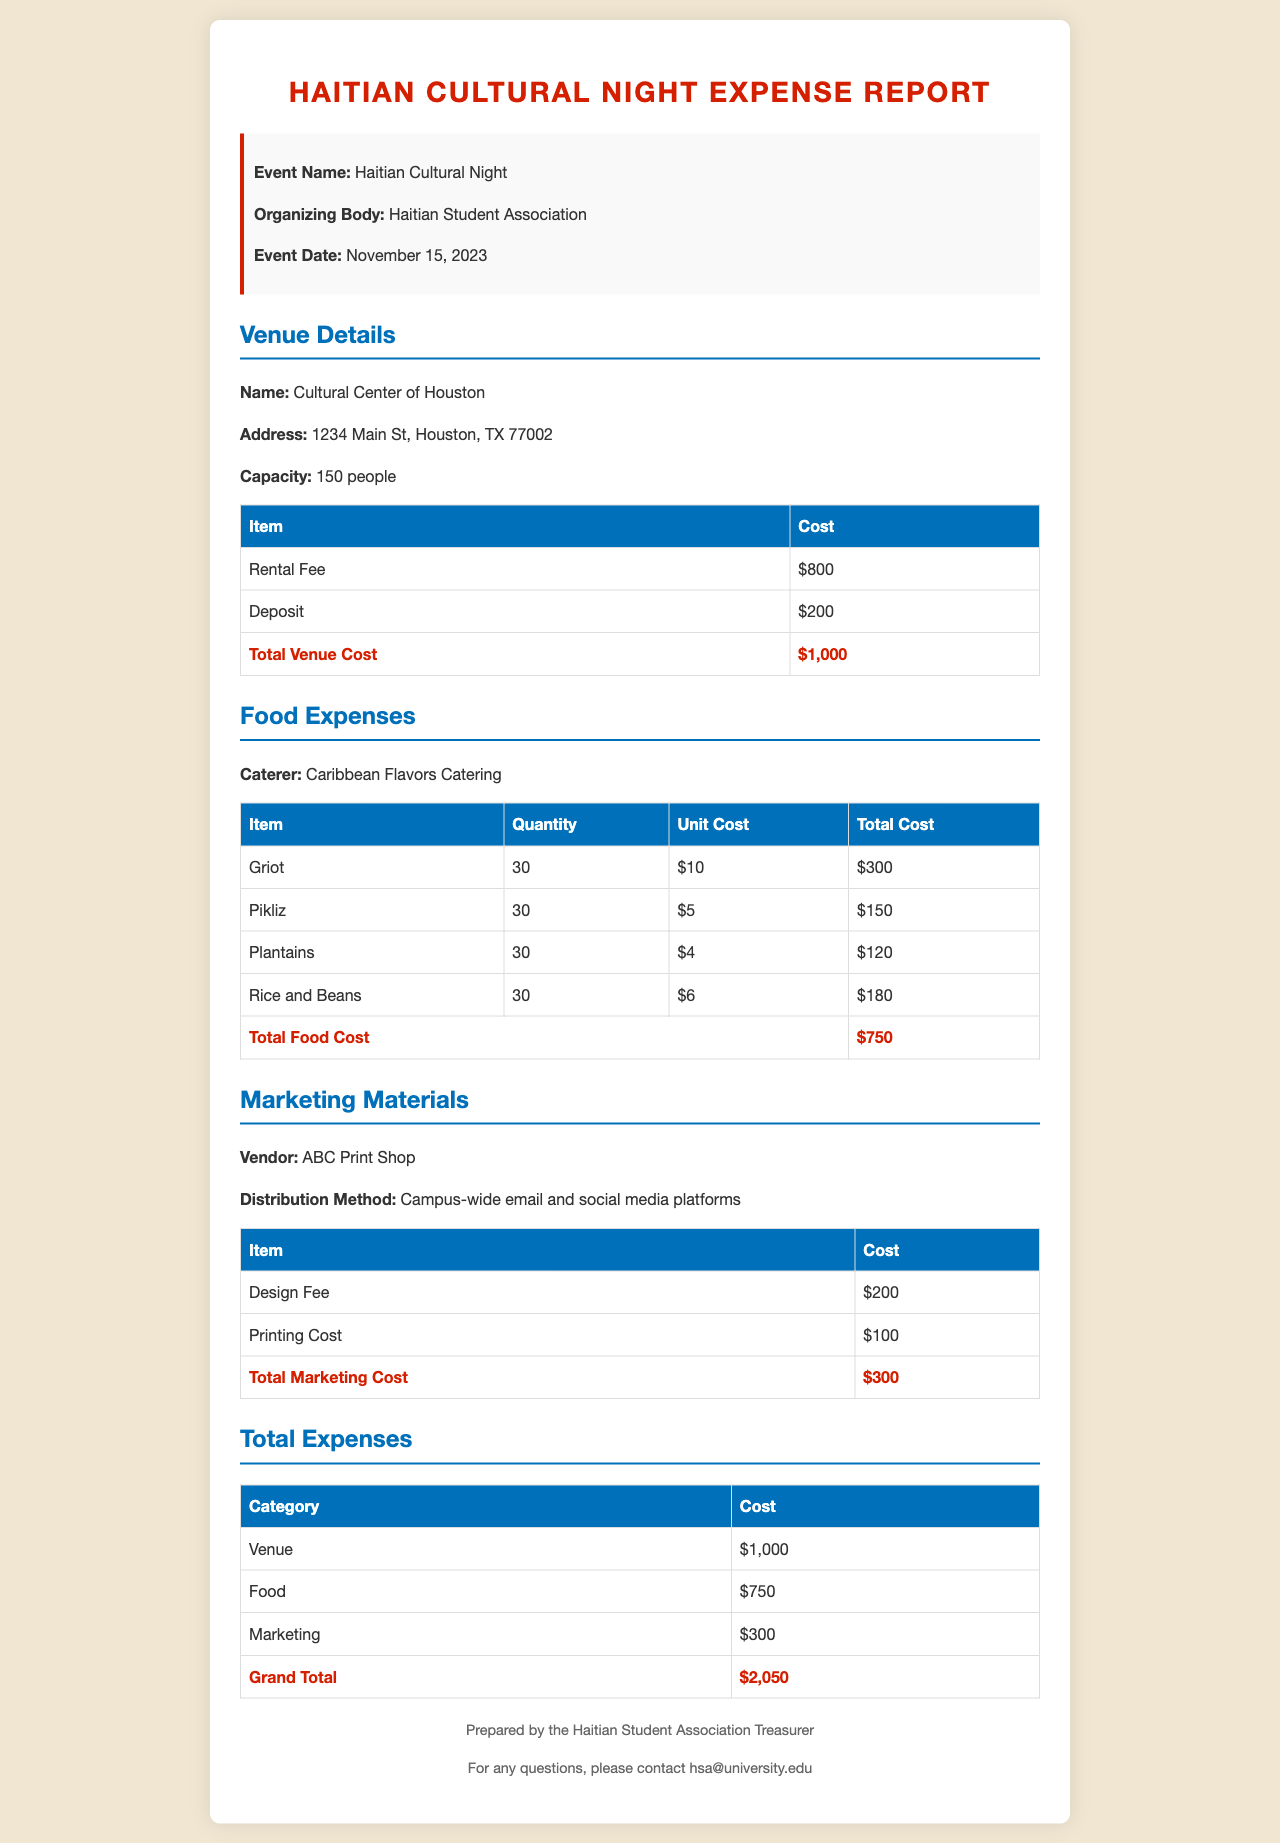what is the event date? The event date is clearly stated in the document as November 15, 2023.
Answer: November 15, 2023 who is the caterer? The caterer is listed under the food expenses section of the document as Caribbean Flavors Catering.
Answer: Caribbean Flavors Catering what is the total marketing cost? The total marketing cost is indicated in the marketing materials section of the document as $300.
Answer: $300 how many people can the venue accommodate? The capacity of the venue is provided, which is 150 people.
Answer: 150 what was the cost of Griot? The cost for Griot is mentioned in the food expenses table as $300 for 30 servings.
Answer: $300 what is the total venue cost? The total cost for the venue is summed up in the venue details as $1,000.
Answer: $1,000 what are the distribution methods for marketing? The distribution methods for marketing materials include campus-wide email and social media platforms.
Answer: Campus-wide email and social media platforms who prepared the report? The document specifies that it was prepared by the Haitian Student Association Treasurer.
Answer: Haitian Student Association Treasurer what is the grand total of the expenses? The grand total is the sum of all expenses listed and is stated as $2,050 in the total expenses section.
Answer: $2,050 